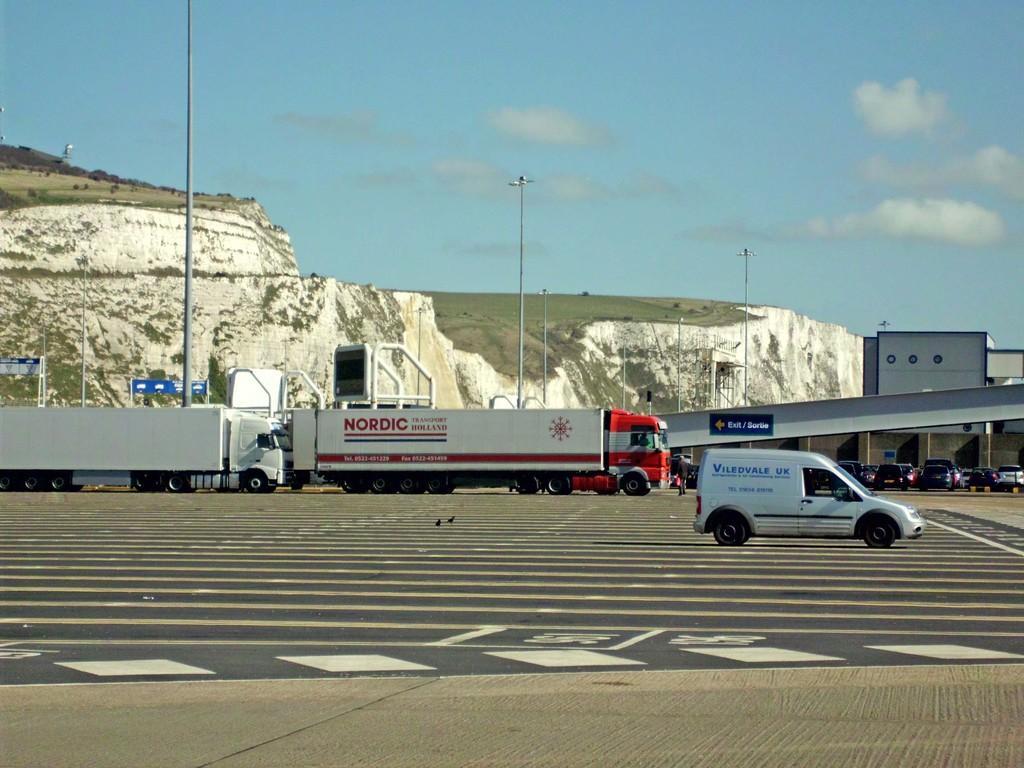Can you describe this image briefly? In the image I can see some trucks, cars and other vehicles on the road and behind there are some rocks and some poles. 